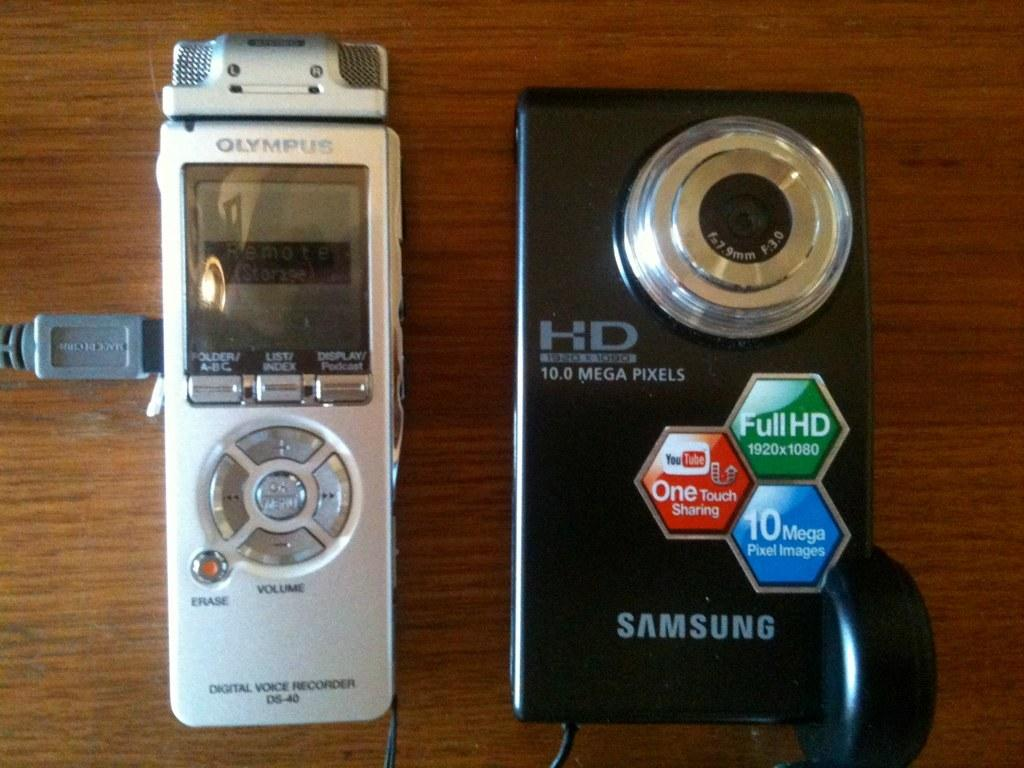<image>
Create a compact narrative representing the image presented. Black Samsung camera that can take up to 10.0 mega pixels next to an Olympus device. 